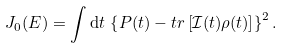<formula> <loc_0><loc_0><loc_500><loc_500>J _ { 0 } ( E ) = \int \mathrm d t \, \left \{ P ( t ) - t r \left [ \mathcal { I } ( t ) \rho ( t ) \right ] \right \} ^ { 2 } .</formula> 